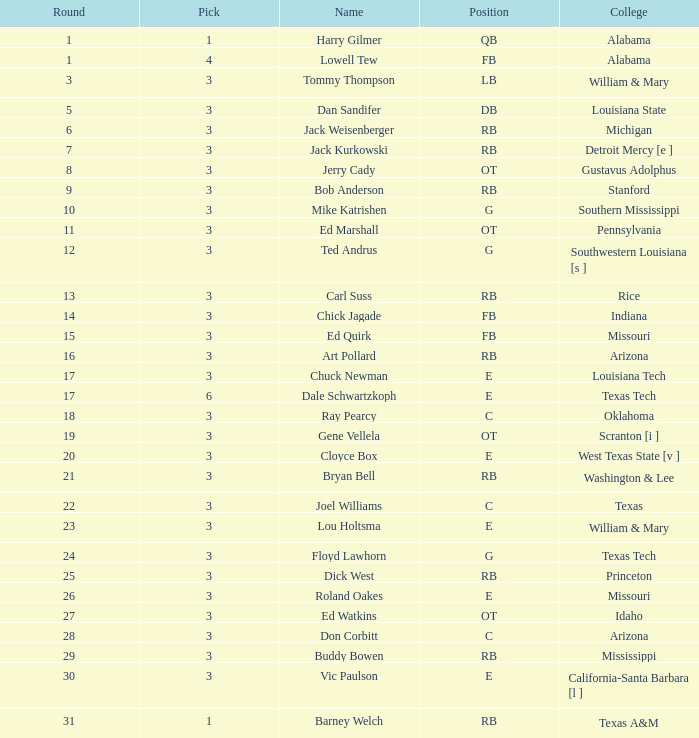How much Overall has a Name of bob anderson? 1.0. 